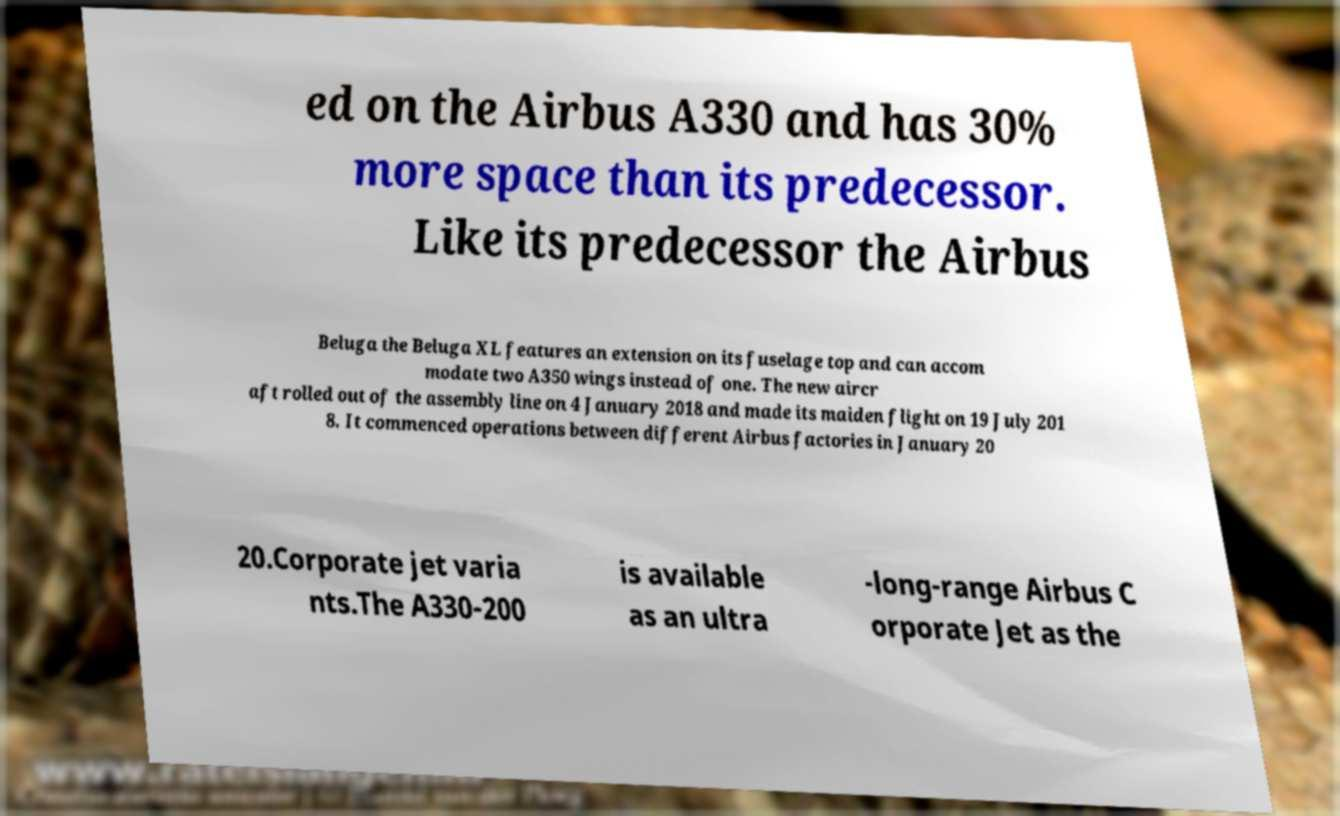What messages or text are displayed in this image? I need them in a readable, typed format. ed on the Airbus A330 and has 30% more space than its predecessor. Like its predecessor the Airbus Beluga the Beluga XL features an extension on its fuselage top and can accom modate two A350 wings instead of one. The new aircr aft rolled out of the assembly line on 4 January 2018 and made its maiden flight on 19 July 201 8. It commenced operations between different Airbus factories in January 20 20.Corporate jet varia nts.The A330-200 is available as an ultra -long-range Airbus C orporate Jet as the 